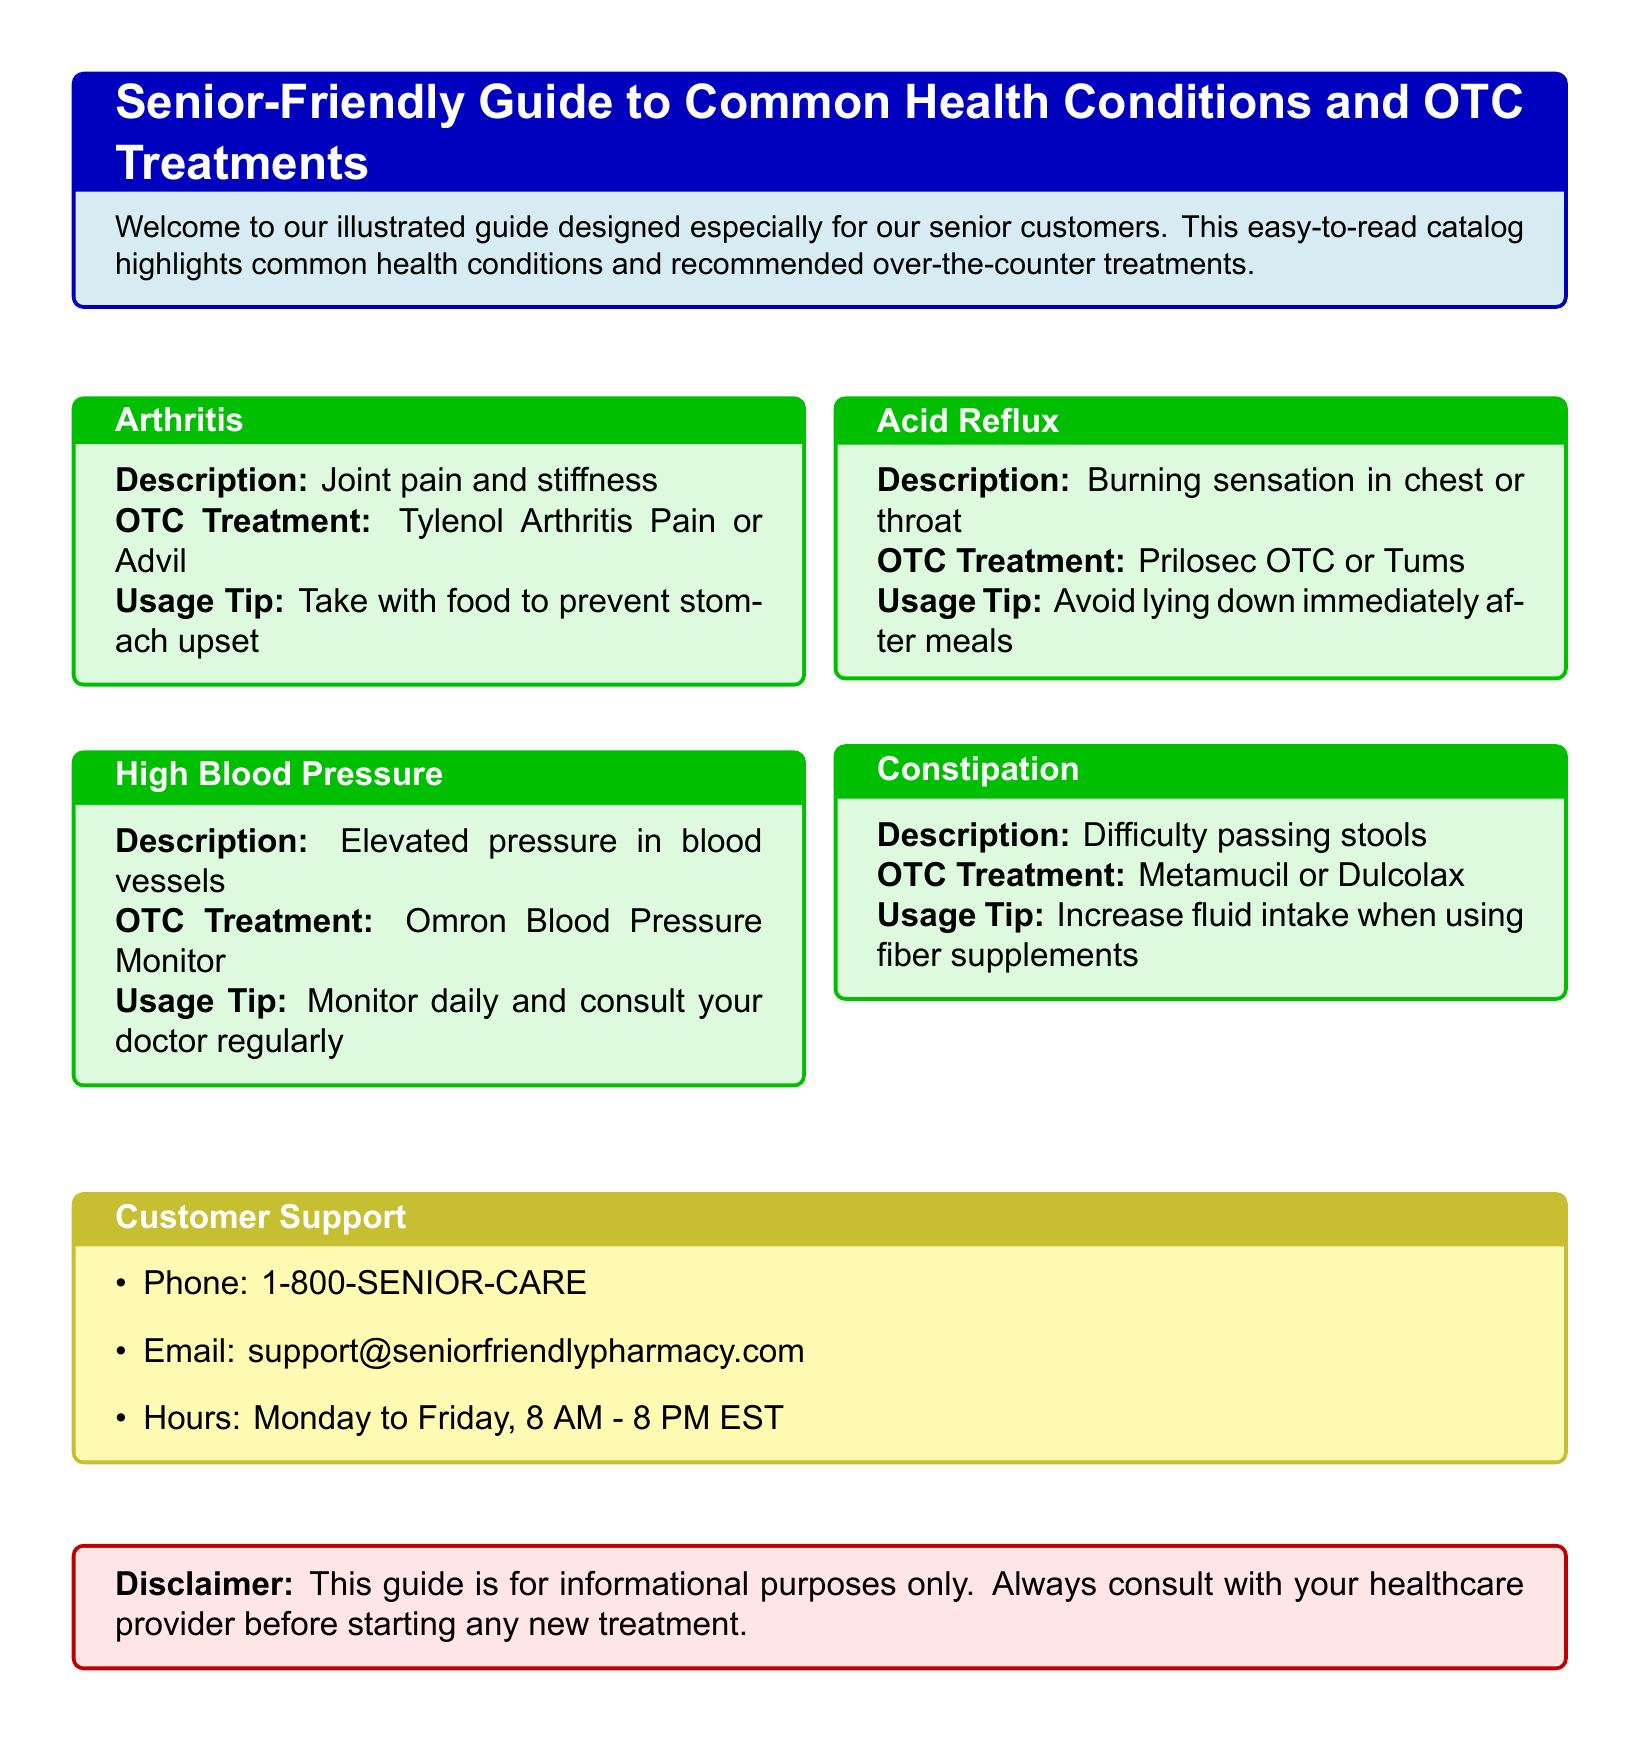What is the main purpose of the guide? The guide is designed especially for senior customers, highlighting common health conditions and recommended over-the-counter treatments.
Answer: To assist senior customers What is one over-the-counter treatment for arthritis? The document lists Tylenol Arthritis Pain or Advil as OTC treatments for arthritis.
Answer: Tylenol Arthritis Pain or Advil What should seniors avoid doing after meals if they suffer from acid reflux? The guide recommends avoiding lying down immediately after meals to prevent worsening the condition.
Answer: Lying down immediately after meals How can seniors manage constipation, according to the guide? The document advises using Metamucil or Dulcolax to manage constipation and increasing fluid intake when using fiber supplements.
Answer: Metamucil or Dulcolax What is the contact email for customer support? The document provides the email support@seniorfriendlypharmacy.com for customer support inquiries.
Answer: support@seniorfriendlypharmacy.com Which device is recommended for monitoring high blood pressure? The guide recommends the Omron Blood Pressure Monitor for regular monitoring.
Answer: Omron Blood Pressure Monitor What is a usage tip for taking Tylenol Arthritis Pain or Advil? The guide suggests that it should be taken with food to prevent stomach upset.
Answer: Take with food to prevent stomach upset What are the customer support hours? The listed customer support hours are Monday to Friday, 8 AM - 8 PM EST.
Answer: Monday to Friday, 8 AM - 8 PM EST 